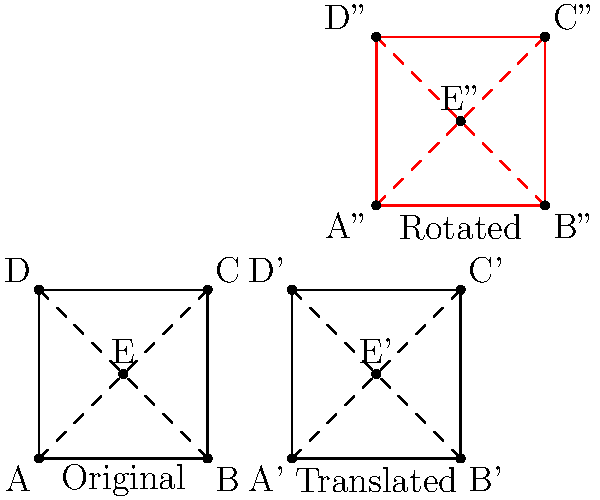A gardener is observing the growth pattern of a thyme plant in their herb garden. The plant's initial square-shaped growth area is represented by ABCD with center point E. After a week, the plant has undergone two transformations:

1. A translation of 6 units to the right, resulting in A'B'C'D'.
2. A 90° clockwise rotation around point B', resulting in A''B''C''D''.

If the original square ABCD has a side length of 4 units, what are the coordinates of point E'' after both transformations? Let's approach this step-by-step:

1. Initial coordinates:
   A(0,0), B(4,0), C(4,4), D(0,4), E(2,2)

2. After translation of 6 units right:
   A'(6,0), B'(10,0), C'(10,4), D'(6,4), E'(8,2)

3. For the 90° clockwise rotation around B'(10,0):
   - We can use the rotation formula:
     $x' = (x - x_center) \cos \theta - (y - y_center) \sin \theta + x_center$
     $y' = (x - x_center) \sin \theta + (y - y_center) \cos \theta + y_center$
   - Where $(x_center, y_center)$ is B'(10,0), and $\theta = -90°$ (clockwise)
   - $\cos(-90°) = 0$, $\sin(-90°) = -1$

4. Applying the rotation to E'(8,2):
   $x'' = (8 - 10) \cdot 0 - (2 - 0) \cdot (-1) + 10 = 12$
   $y'' = (8 - 10) \cdot (-1) + (2 - 0) \cdot 0 + 0 = 2$

Therefore, the coordinates of E'' after both transformations are (12,2).
Answer: (12,2) 